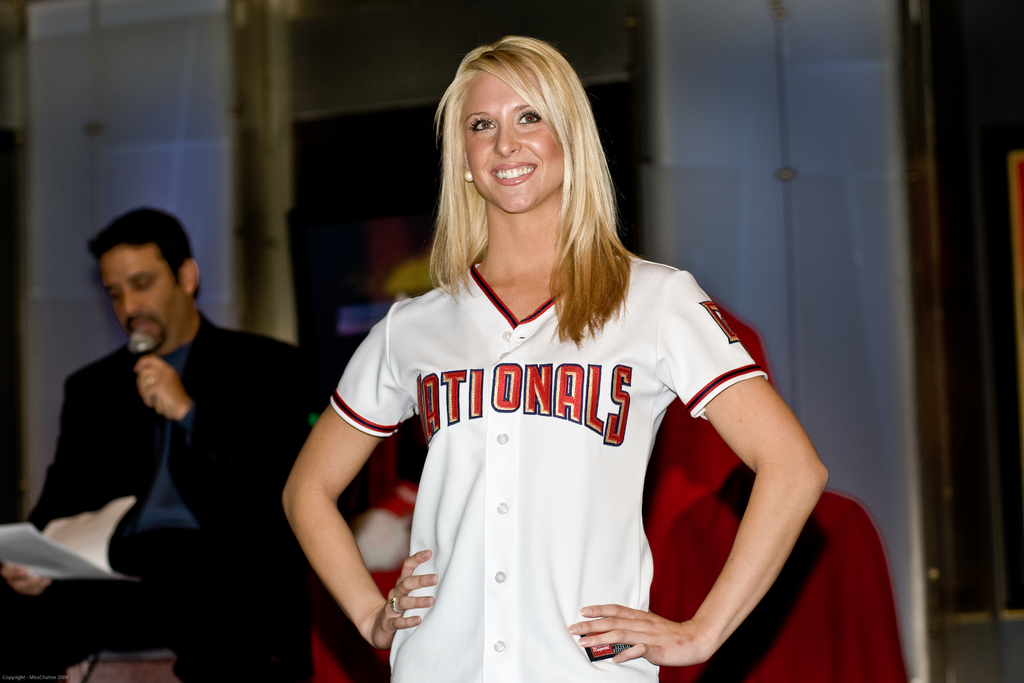Can you describe the background setting and its relevance? The background features a subdued setting with a man speaking into a microphone, suggesting this photo was taken during a public speaking segment, possibly at a team-related press conference or announcement. 